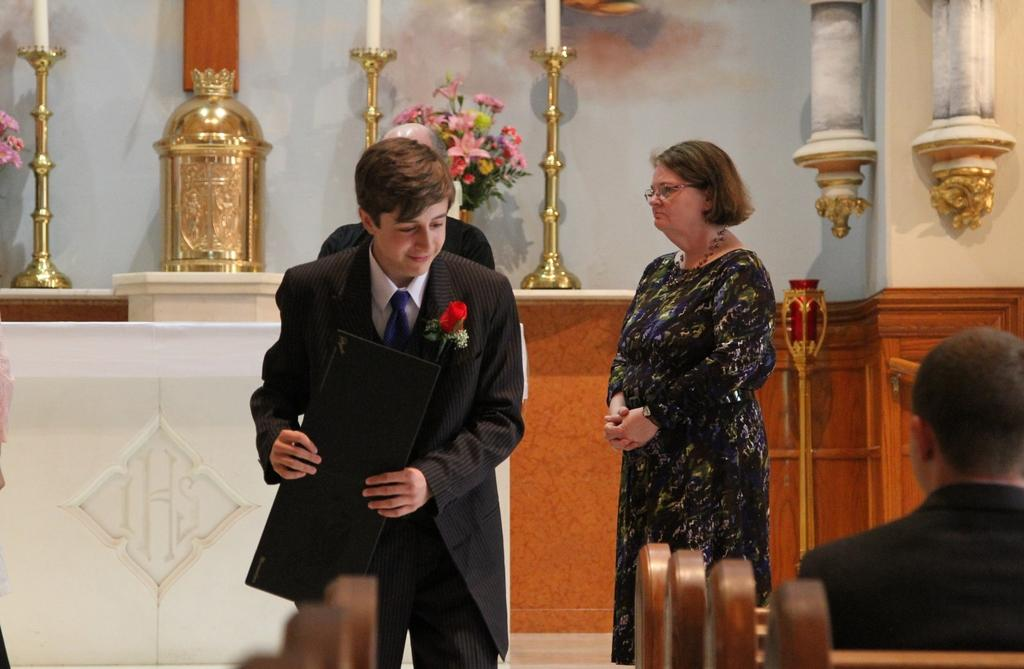What is the person wearing in the image? The person is wearing a coat in the image. What is the person holding in the image? The person is holding an object in the image. Can you describe the woman on the right side of the image? There is a woman standing on the right side of the image. What is the position of one of the people in the image? There is a person sitting in the image. What type of decorative item can be seen in the image? There is a flower vase in the image. What type of celery is being used as a decoration in the image? There is no celery present in the image; it is a flower vase that serves as a decorative item. What type of silk material is draped over the person sitting in the image? There is no silk material mentioned in the image; the person sitting is not described in terms of clothing or fabric. 